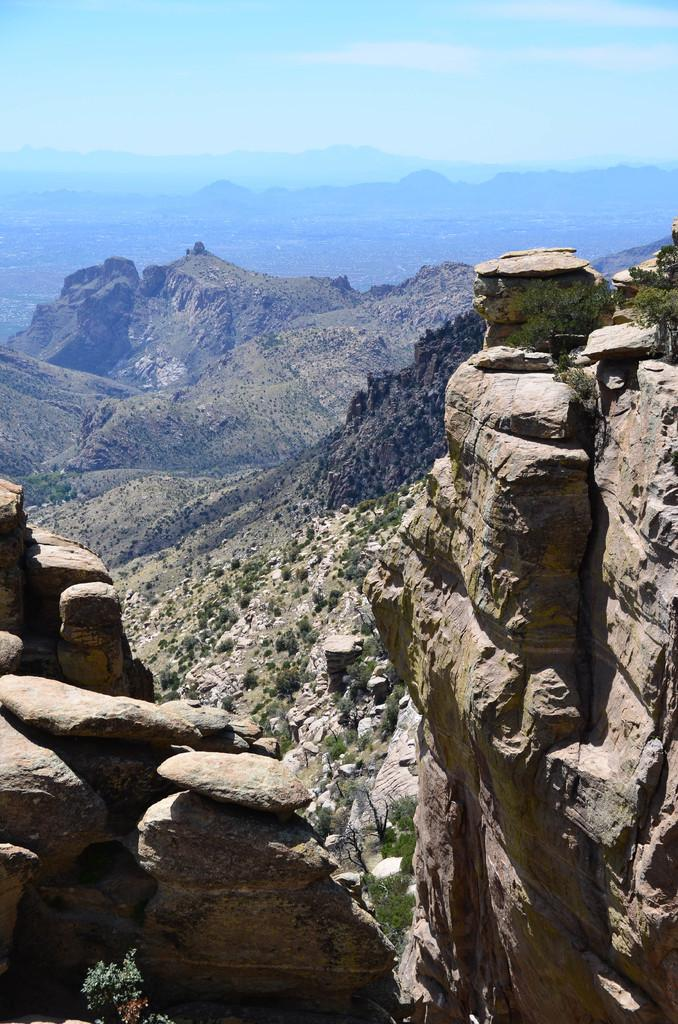What type of natural landform can be seen in the image? There are mountains in the image. What type of vegetation is present in the image? There are trees in the image. What other geological features can be seen in the image? There are rocks in the image. What is the color of the sky in the image? The sky is blue and white in color. Can you tell me how the moon is affecting the mind of the trees in the image? There is no moon present in the image, and trees do not have minds. 